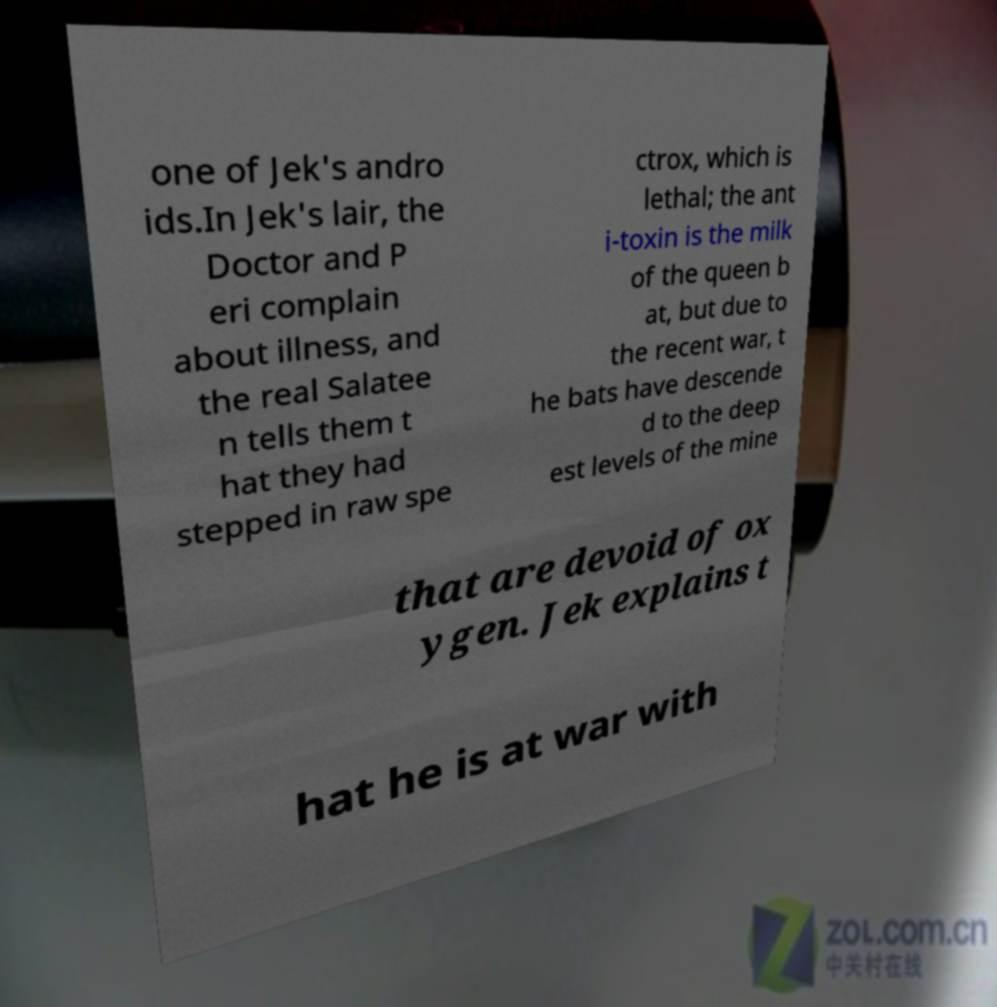Please read and relay the text visible in this image. What does it say? one of Jek's andro ids.In Jek's lair, the Doctor and P eri complain about illness, and the real Salatee n tells them t hat they had stepped in raw spe ctrox, which is lethal; the ant i-toxin is the milk of the queen b at, but due to the recent war, t he bats have descende d to the deep est levels of the mine that are devoid of ox ygen. Jek explains t hat he is at war with 